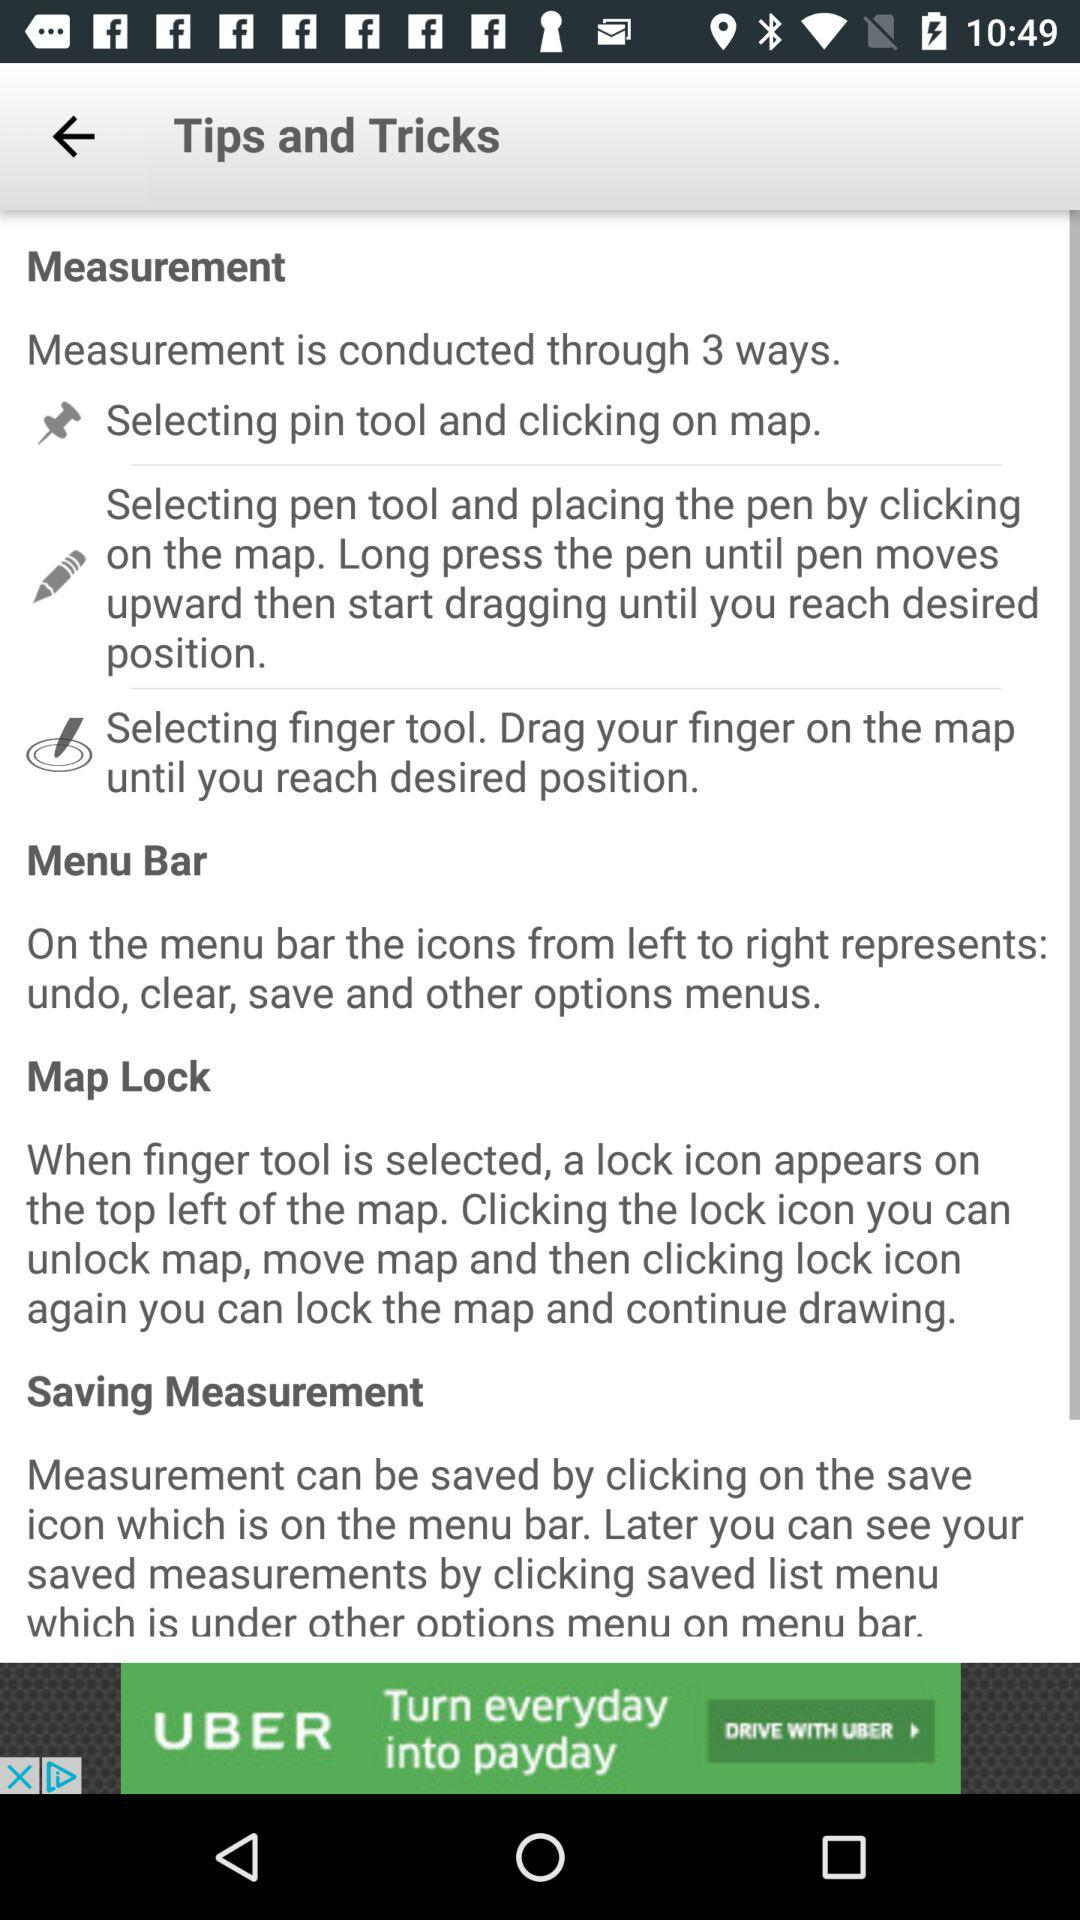Through how many ways is measurement conducted? Measurement is conducted in 3 ways. 